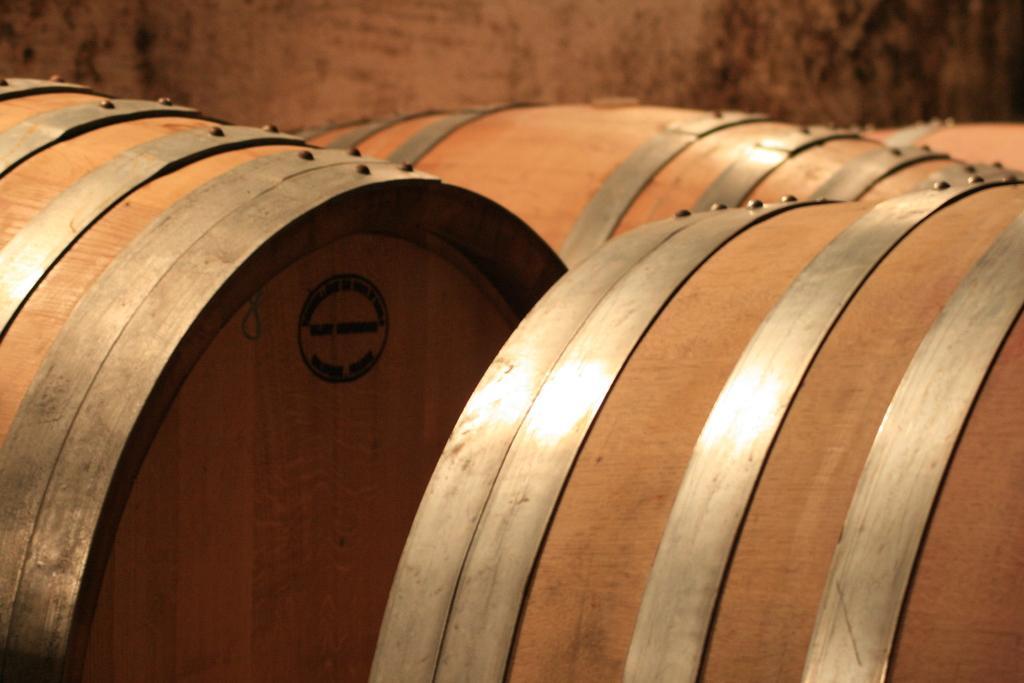Describe this image in one or two sentences. In the image there are many wooden barrels, in the back there is wall. 